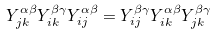Convert formula to latex. <formula><loc_0><loc_0><loc_500><loc_500>Y ^ { \alpha \beta } _ { j k } Y ^ { \beta \gamma } _ { i k } Y ^ { \alpha \beta } _ { i j } = Y ^ { \beta \gamma } _ { i j } Y ^ { \alpha \beta } _ { i k } Y ^ { \beta \gamma } _ { j k }</formula> 